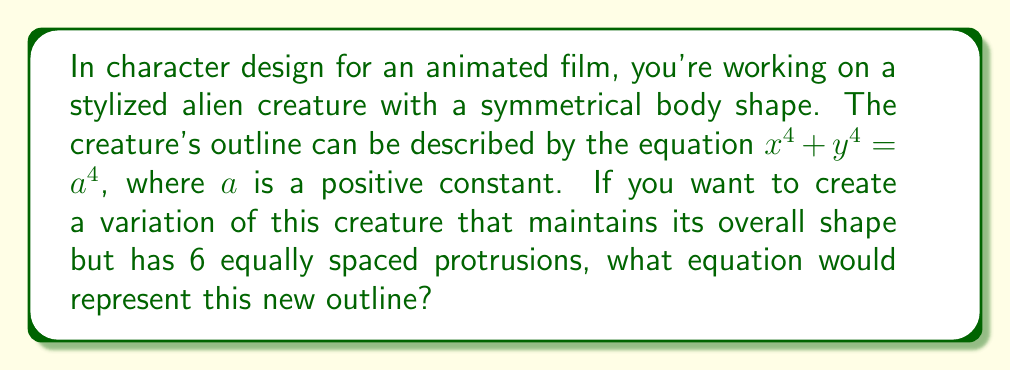Solve this math problem. To solve this problem, we'll follow these steps:

1) The original equation $x^4 + y^4 = a^4$ represents a squircle, which has 4-fold rotational symmetry.

2) To create 6 equally spaced protrusions, we need to modify the equation to have 6-fold rotational symmetry.

3) In algebraic geometry, we can achieve this by using the following general form:

   $$(x^2 + y^2)^3 + k(x^2 - 3y^2)x^3 = a^6$$

   Where $k$ is a constant that determines the "pointiness" of the protrusions.

4) To maintain a shape similar to the original, we want relatively subtle protrusions. A good value for $k$ in this case would be 2.

5) Substituting $k=2$ into the general equation:

   $$(x^2 + y^2)^3 + 2(x^2 - 3y^2)x^3 = a^6$$

6) This equation will create a shape with 6 equally spaced protrusions while maintaining an overall circular form similar to the original design.

[asy]
import graph;
size(200);
real f(real x, real y) {
  return (x^2+y^2)^3 + 2*(x^2-3*y^2)*x^3 - 1;
}
draw(contour(f,(-1.2,-1.2),(1.2,1.2),new real[]{0}));
[/asy]
Answer: $(x^2 + y^2)^3 + 2(x^2 - 3y^2)x^3 = a^6$ 